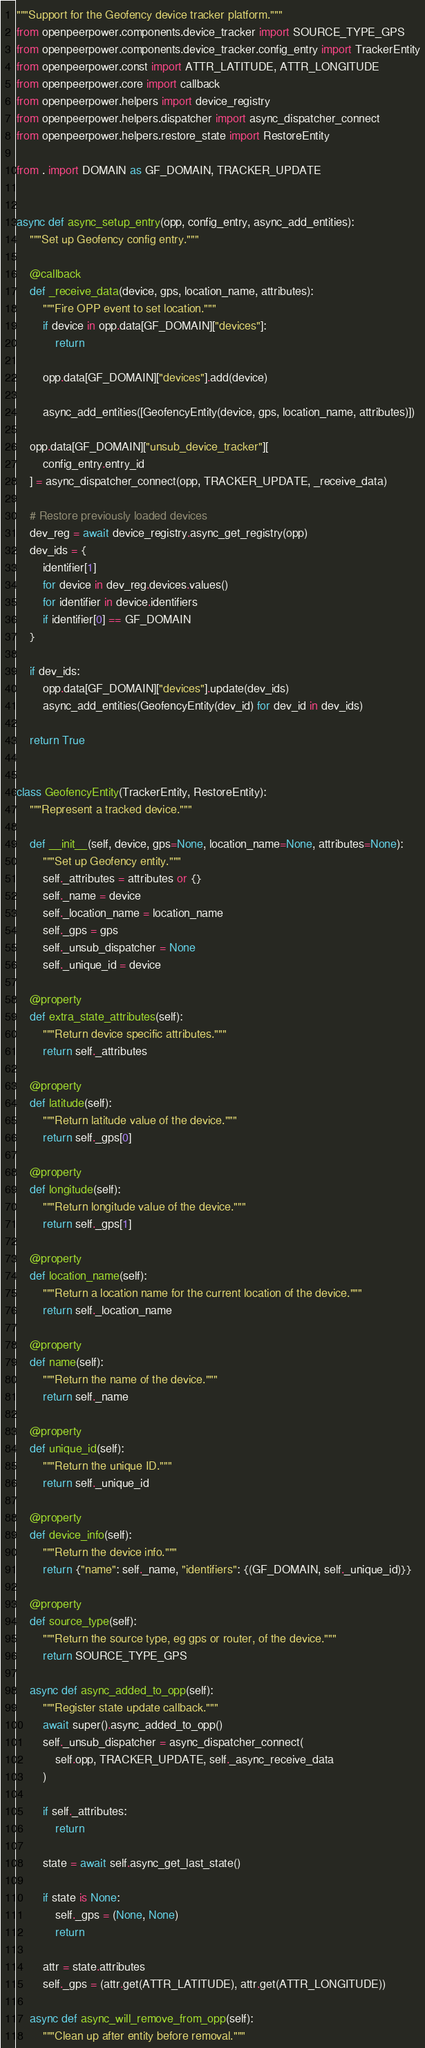<code> <loc_0><loc_0><loc_500><loc_500><_Python_>"""Support for the Geofency device tracker platform."""
from openpeerpower.components.device_tracker import SOURCE_TYPE_GPS
from openpeerpower.components.device_tracker.config_entry import TrackerEntity
from openpeerpower.const import ATTR_LATITUDE, ATTR_LONGITUDE
from openpeerpower.core import callback
from openpeerpower.helpers import device_registry
from openpeerpower.helpers.dispatcher import async_dispatcher_connect
from openpeerpower.helpers.restore_state import RestoreEntity

from . import DOMAIN as GF_DOMAIN, TRACKER_UPDATE


async def async_setup_entry(opp, config_entry, async_add_entities):
    """Set up Geofency config entry."""

    @callback
    def _receive_data(device, gps, location_name, attributes):
        """Fire OPP event to set location."""
        if device in opp.data[GF_DOMAIN]["devices"]:
            return

        opp.data[GF_DOMAIN]["devices"].add(device)

        async_add_entities([GeofencyEntity(device, gps, location_name, attributes)])

    opp.data[GF_DOMAIN]["unsub_device_tracker"][
        config_entry.entry_id
    ] = async_dispatcher_connect(opp, TRACKER_UPDATE, _receive_data)

    # Restore previously loaded devices
    dev_reg = await device_registry.async_get_registry(opp)
    dev_ids = {
        identifier[1]
        for device in dev_reg.devices.values()
        for identifier in device.identifiers
        if identifier[0] == GF_DOMAIN
    }

    if dev_ids:
        opp.data[GF_DOMAIN]["devices"].update(dev_ids)
        async_add_entities(GeofencyEntity(dev_id) for dev_id in dev_ids)

    return True


class GeofencyEntity(TrackerEntity, RestoreEntity):
    """Represent a tracked device."""

    def __init__(self, device, gps=None, location_name=None, attributes=None):
        """Set up Geofency entity."""
        self._attributes = attributes or {}
        self._name = device
        self._location_name = location_name
        self._gps = gps
        self._unsub_dispatcher = None
        self._unique_id = device

    @property
    def extra_state_attributes(self):
        """Return device specific attributes."""
        return self._attributes

    @property
    def latitude(self):
        """Return latitude value of the device."""
        return self._gps[0]

    @property
    def longitude(self):
        """Return longitude value of the device."""
        return self._gps[1]

    @property
    def location_name(self):
        """Return a location name for the current location of the device."""
        return self._location_name

    @property
    def name(self):
        """Return the name of the device."""
        return self._name

    @property
    def unique_id(self):
        """Return the unique ID."""
        return self._unique_id

    @property
    def device_info(self):
        """Return the device info."""
        return {"name": self._name, "identifiers": {(GF_DOMAIN, self._unique_id)}}

    @property
    def source_type(self):
        """Return the source type, eg gps or router, of the device."""
        return SOURCE_TYPE_GPS

    async def async_added_to_opp(self):
        """Register state update callback."""
        await super().async_added_to_opp()
        self._unsub_dispatcher = async_dispatcher_connect(
            self.opp, TRACKER_UPDATE, self._async_receive_data
        )

        if self._attributes:
            return

        state = await self.async_get_last_state()

        if state is None:
            self._gps = (None, None)
            return

        attr = state.attributes
        self._gps = (attr.get(ATTR_LATITUDE), attr.get(ATTR_LONGITUDE))

    async def async_will_remove_from_opp(self):
        """Clean up after entity before removal."""</code> 